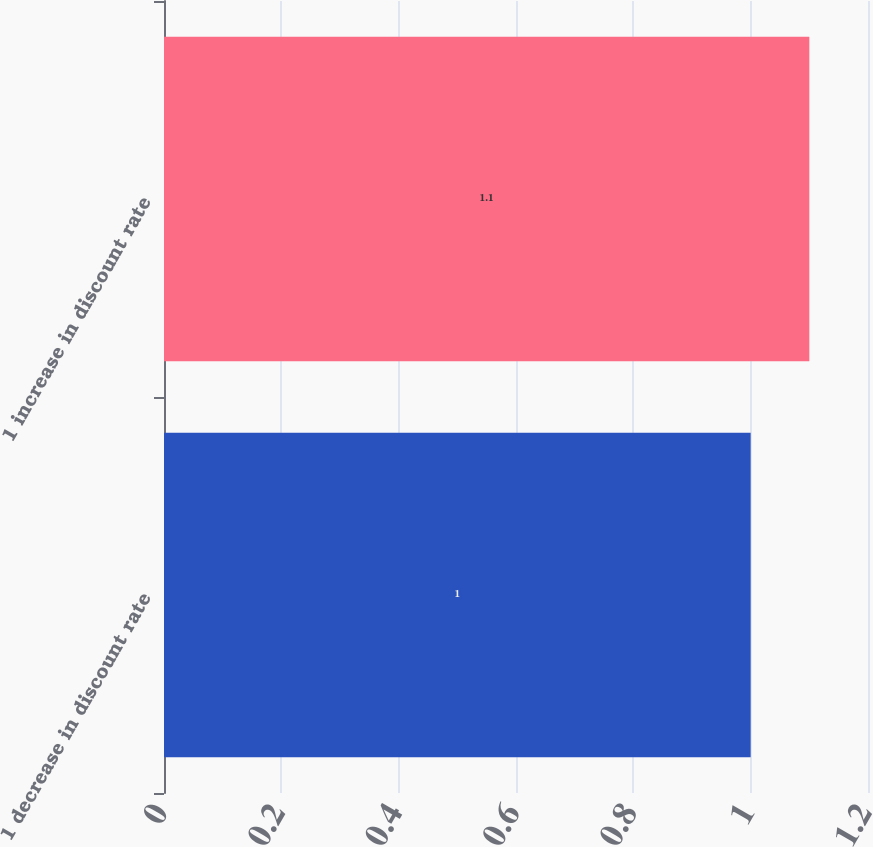<chart> <loc_0><loc_0><loc_500><loc_500><bar_chart><fcel>1 decrease in discount rate<fcel>1 increase in discount rate<nl><fcel>1<fcel>1.1<nl></chart> 